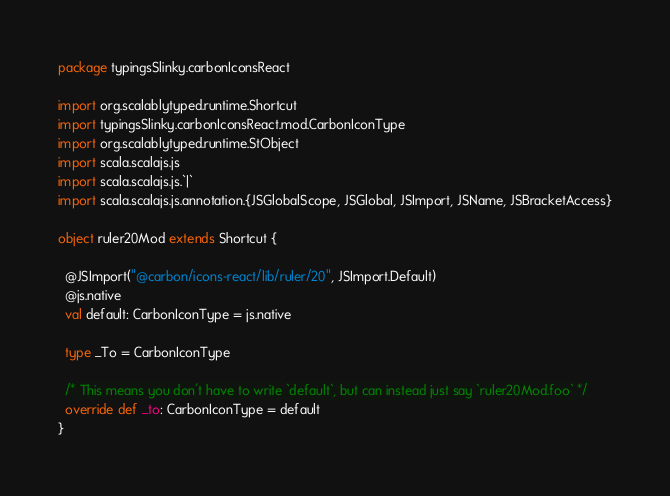<code> <loc_0><loc_0><loc_500><loc_500><_Scala_>package typingsSlinky.carbonIconsReact

import org.scalablytyped.runtime.Shortcut
import typingsSlinky.carbonIconsReact.mod.CarbonIconType
import org.scalablytyped.runtime.StObject
import scala.scalajs.js
import scala.scalajs.js.`|`
import scala.scalajs.js.annotation.{JSGlobalScope, JSGlobal, JSImport, JSName, JSBracketAccess}

object ruler20Mod extends Shortcut {
  
  @JSImport("@carbon/icons-react/lib/ruler/20", JSImport.Default)
  @js.native
  val default: CarbonIconType = js.native
  
  type _To = CarbonIconType
  
  /* This means you don't have to write `default`, but can instead just say `ruler20Mod.foo` */
  override def _to: CarbonIconType = default
}
</code> 